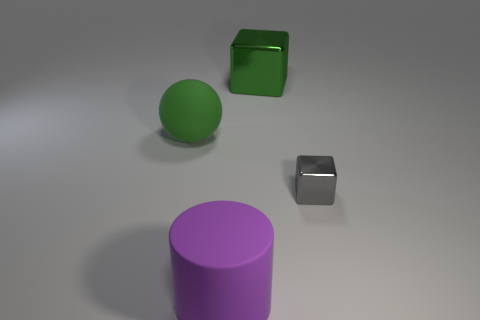Add 1 big blue rubber balls. How many objects exist? 5 Subtract all gray cubes. How many cubes are left? 1 Subtract all spheres. How many objects are left? 3 Subtract 1 cubes. How many cubes are left? 1 Subtract all gray cylinders. Subtract all cyan cubes. How many cylinders are left? 1 Subtract all blue balls. How many green cubes are left? 1 Subtract all cylinders. Subtract all green objects. How many objects are left? 1 Add 1 big things. How many big things are left? 4 Add 1 tiny green metal objects. How many tiny green metal objects exist? 1 Subtract 0 yellow cylinders. How many objects are left? 4 